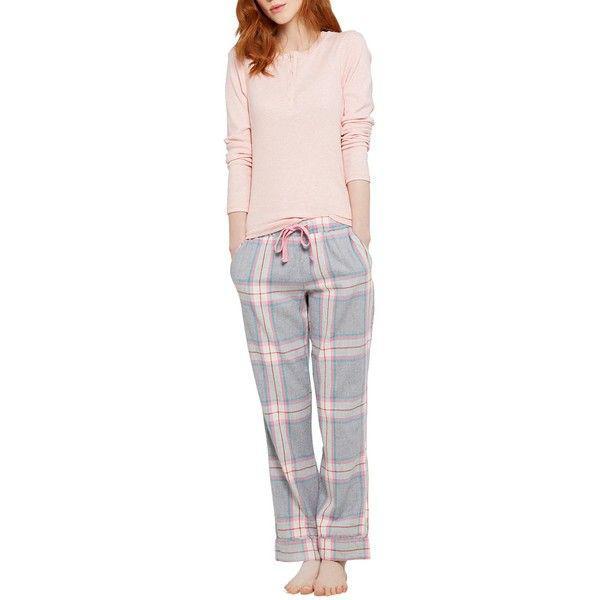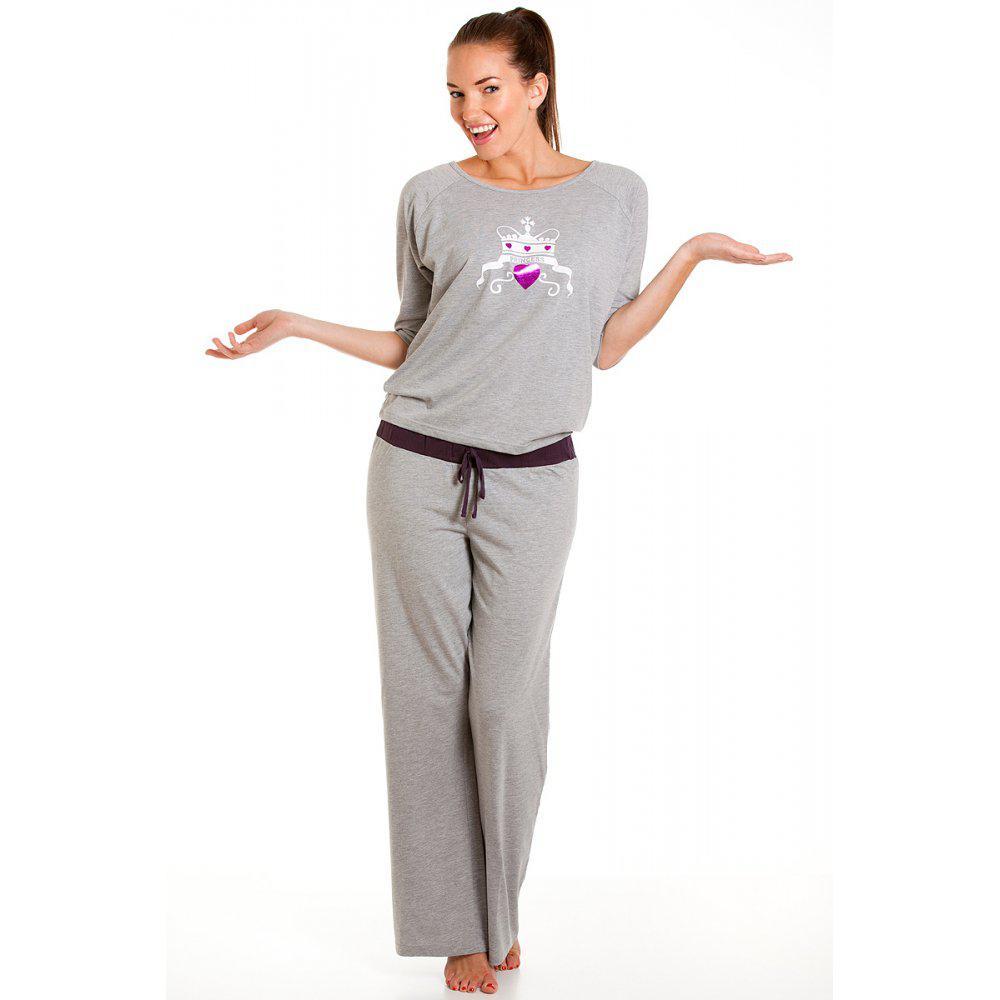The first image is the image on the left, the second image is the image on the right. Given the left and right images, does the statement "At least one pair of pajamas are polka-dotted." hold true? Answer yes or no. No. The first image is the image on the left, the second image is the image on the right. Analyze the images presented: Is the assertion "The image on the left has a mannequin wearing sleep attire." valid? Answer yes or no. No. 